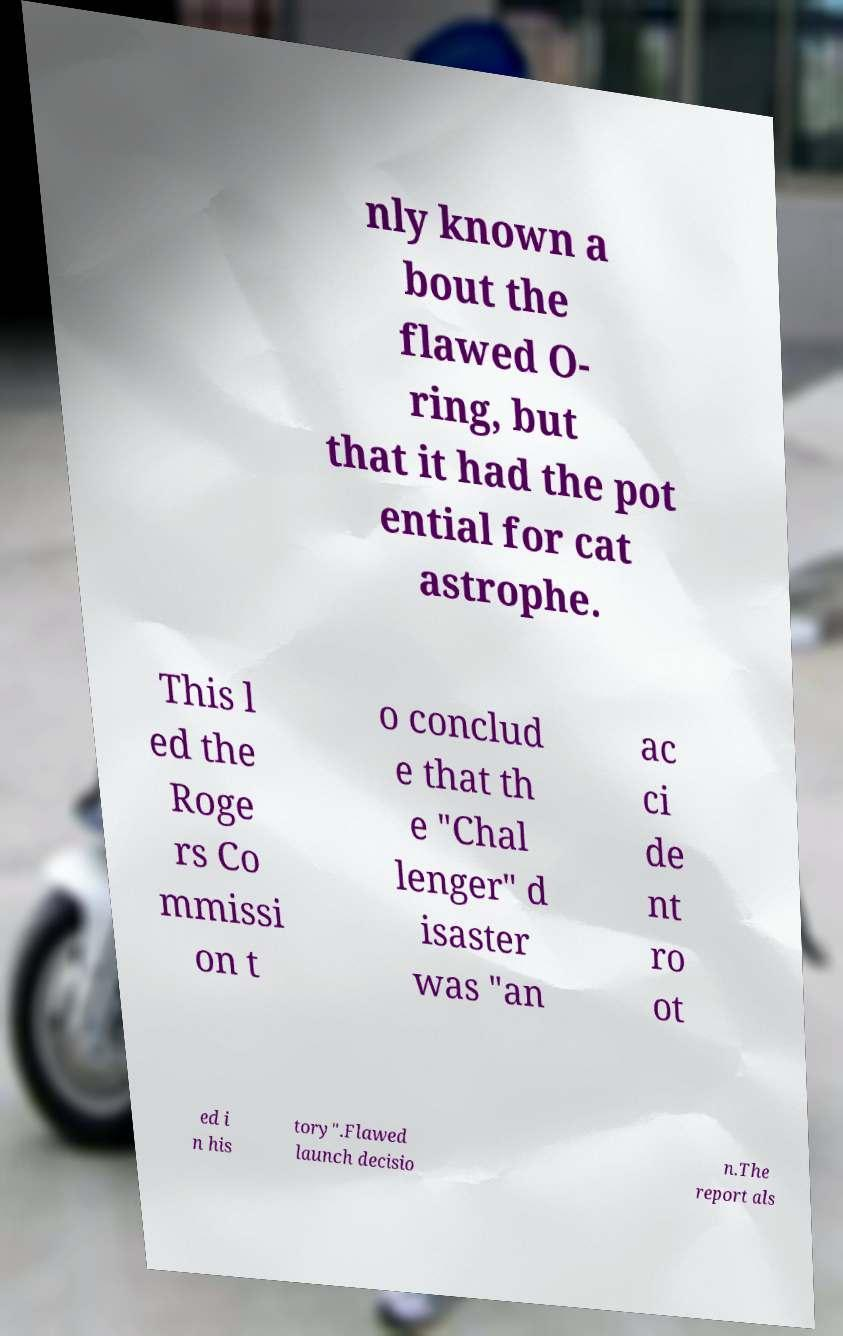There's text embedded in this image that I need extracted. Can you transcribe it verbatim? nly known a bout the flawed O- ring, but that it had the pot ential for cat astrophe. This l ed the Roge rs Co mmissi on t o conclud e that th e "Chal lenger" d isaster was "an ac ci de nt ro ot ed i n his tory".Flawed launch decisio n.The report als 